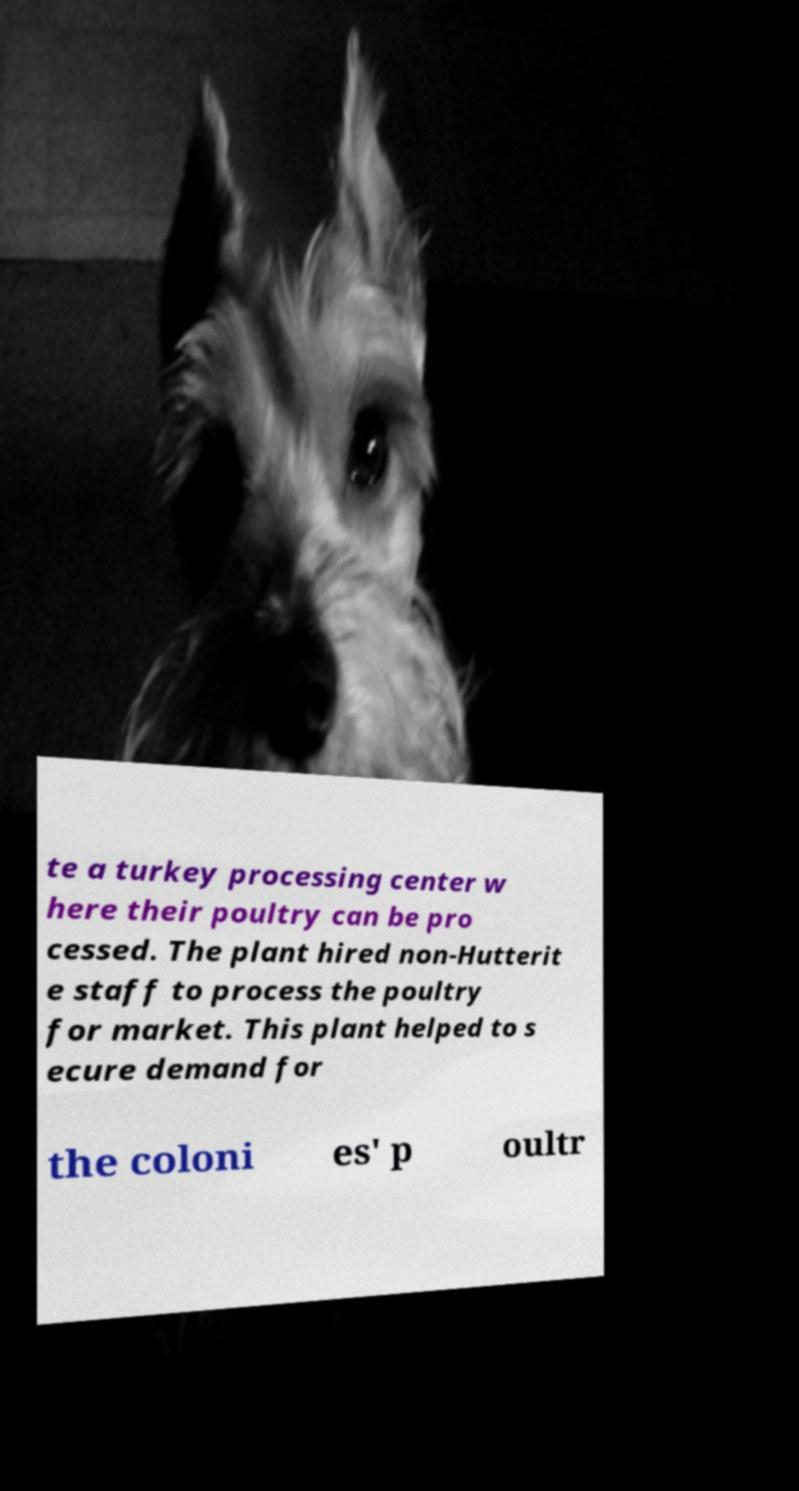Can you read and provide the text displayed in the image?This photo seems to have some interesting text. Can you extract and type it out for me? te a turkey processing center w here their poultry can be pro cessed. The plant hired non-Hutterit e staff to process the poultry for market. This plant helped to s ecure demand for the coloni es' p oultr 